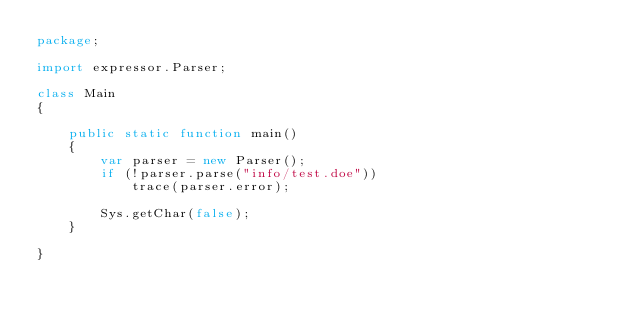Convert code to text. <code><loc_0><loc_0><loc_500><loc_500><_Haxe_>package;

import expressor.Parser;

class Main
{

    public static function main()
    {
        var parser = new Parser();
        if (!parser.parse("info/test.doe"))
            trace(parser.error);
        
        Sys.getChar(false);
    }
    
}</code> 